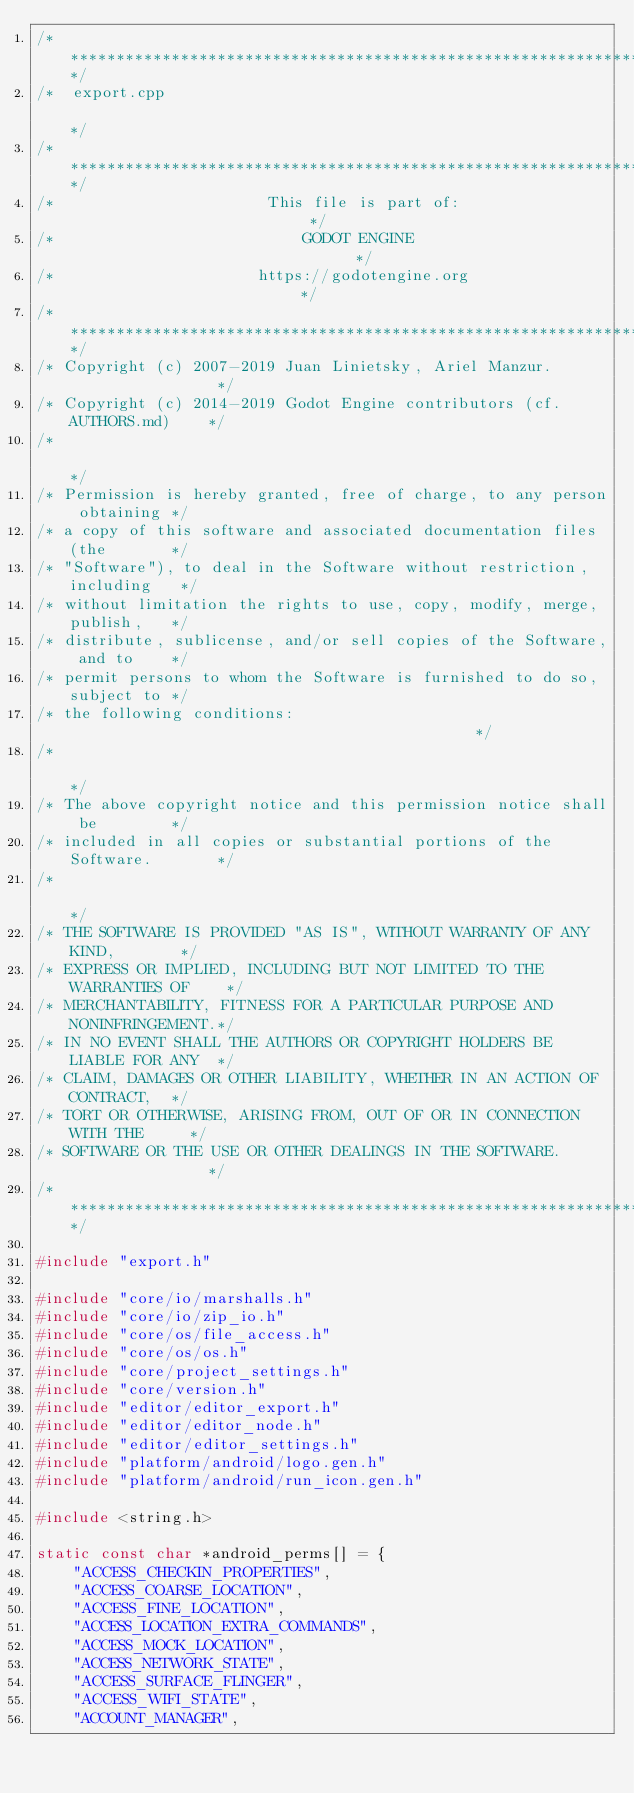<code> <loc_0><loc_0><loc_500><loc_500><_C++_>/*************************************************************************/
/*  export.cpp                                                           */
/*************************************************************************/
/*                       This file is part of:                           */
/*                           GODOT ENGINE                                */
/*                      https://godotengine.org                          */
/*************************************************************************/
/* Copyright (c) 2007-2019 Juan Linietsky, Ariel Manzur.                 */
/* Copyright (c) 2014-2019 Godot Engine contributors (cf. AUTHORS.md)    */
/*                                                                       */
/* Permission is hereby granted, free of charge, to any person obtaining */
/* a copy of this software and associated documentation files (the       */
/* "Software"), to deal in the Software without restriction, including   */
/* without limitation the rights to use, copy, modify, merge, publish,   */
/* distribute, sublicense, and/or sell copies of the Software, and to    */
/* permit persons to whom the Software is furnished to do so, subject to */
/* the following conditions:                                             */
/*                                                                       */
/* The above copyright notice and this permission notice shall be        */
/* included in all copies or substantial portions of the Software.       */
/*                                                                       */
/* THE SOFTWARE IS PROVIDED "AS IS", WITHOUT WARRANTY OF ANY KIND,       */
/* EXPRESS OR IMPLIED, INCLUDING BUT NOT LIMITED TO THE WARRANTIES OF    */
/* MERCHANTABILITY, FITNESS FOR A PARTICULAR PURPOSE AND NONINFRINGEMENT.*/
/* IN NO EVENT SHALL THE AUTHORS OR COPYRIGHT HOLDERS BE LIABLE FOR ANY  */
/* CLAIM, DAMAGES OR OTHER LIABILITY, WHETHER IN AN ACTION OF CONTRACT,  */
/* TORT OR OTHERWISE, ARISING FROM, OUT OF OR IN CONNECTION WITH THE     */
/* SOFTWARE OR THE USE OR OTHER DEALINGS IN THE SOFTWARE.                */
/*************************************************************************/

#include "export.h"

#include "core/io/marshalls.h"
#include "core/io/zip_io.h"
#include "core/os/file_access.h"
#include "core/os/os.h"
#include "core/project_settings.h"
#include "core/version.h"
#include "editor/editor_export.h"
#include "editor/editor_node.h"
#include "editor/editor_settings.h"
#include "platform/android/logo.gen.h"
#include "platform/android/run_icon.gen.h"

#include <string.h>

static const char *android_perms[] = {
	"ACCESS_CHECKIN_PROPERTIES",
	"ACCESS_COARSE_LOCATION",
	"ACCESS_FINE_LOCATION",
	"ACCESS_LOCATION_EXTRA_COMMANDS",
	"ACCESS_MOCK_LOCATION",
	"ACCESS_NETWORK_STATE",
	"ACCESS_SURFACE_FLINGER",
	"ACCESS_WIFI_STATE",
	"ACCOUNT_MANAGER",</code> 